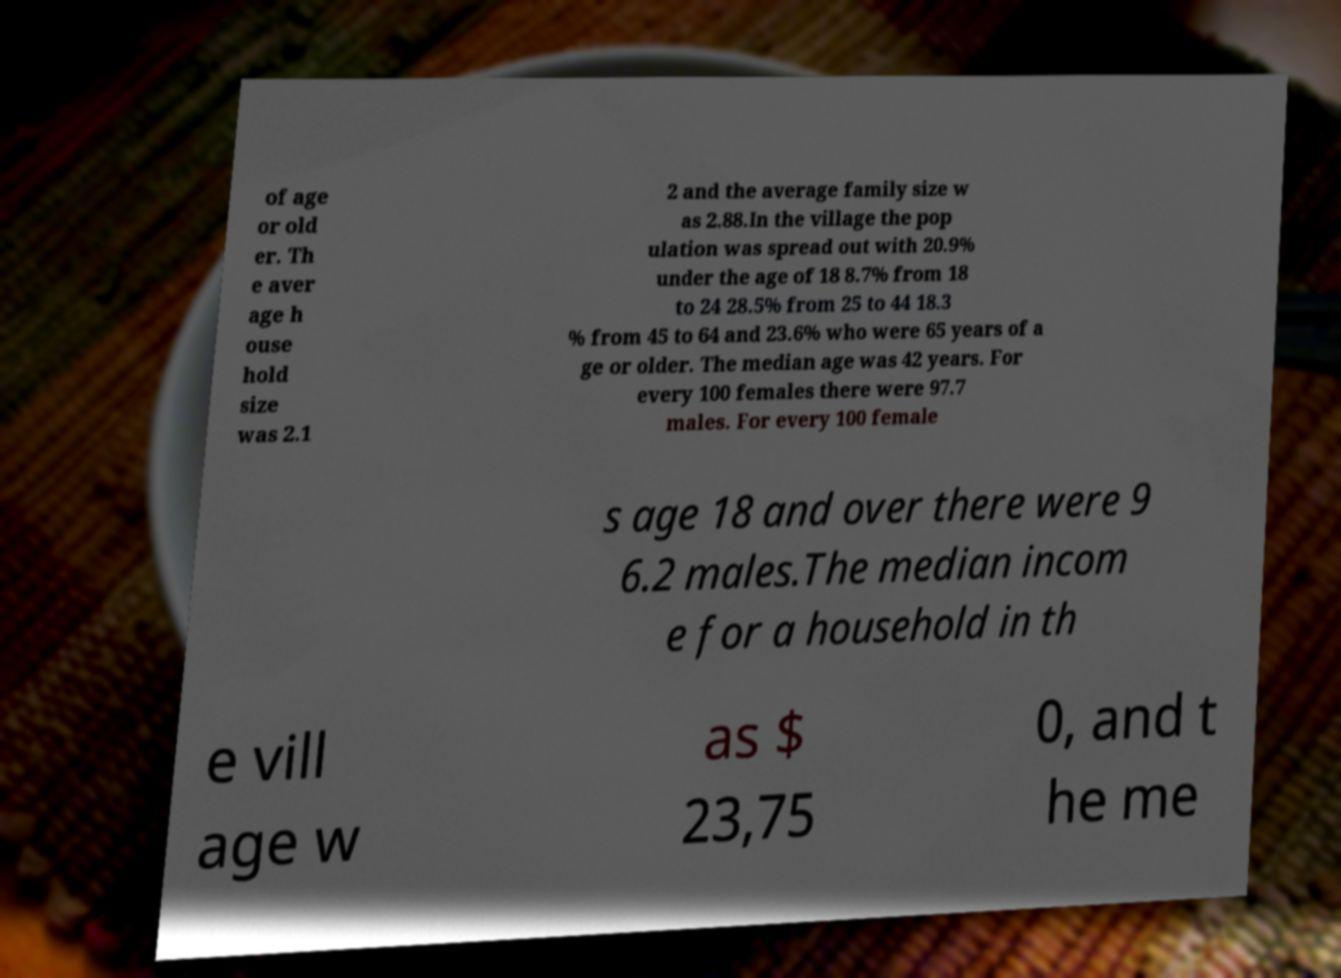Could you assist in decoding the text presented in this image and type it out clearly? of age or old er. Th e aver age h ouse hold size was 2.1 2 and the average family size w as 2.88.In the village the pop ulation was spread out with 20.9% under the age of 18 8.7% from 18 to 24 28.5% from 25 to 44 18.3 % from 45 to 64 and 23.6% who were 65 years of a ge or older. The median age was 42 years. For every 100 females there were 97.7 males. For every 100 female s age 18 and over there were 9 6.2 males.The median incom e for a household in th e vill age w as $ 23,75 0, and t he me 